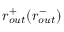<formula> <loc_0><loc_0><loc_500><loc_500>r _ { o u t } ^ { + } ( r _ { o u t } ^ { - } )</formula> 